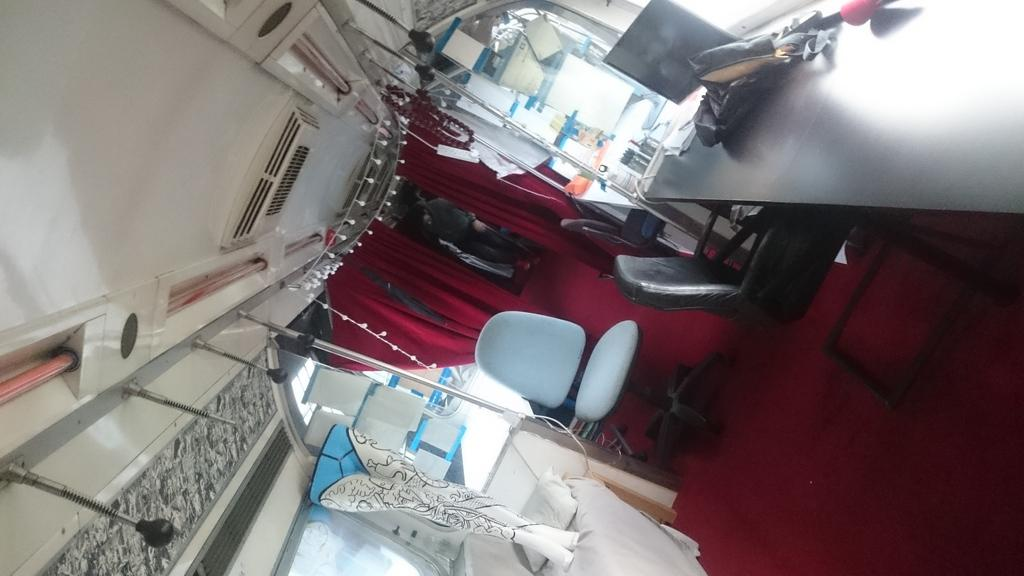What type of furniture is present in the image? There is a bed and chairs in the image. What can be found on the bed? There is a pillow on the bed. What type of windows are in the image? There are glass windows in the image. What is on the table in the image? There are objects on the table in the image. What is the color of the curtains in the background? There are maroon curtains in the background of the image. Are there any people visible in the image? Yes, there are people visible in the background of the image. What type of plantation is visible in the image? There is no plantation present in the image. How many lines can be seen in the image? The image does not contain any lines; it is a photograph of a room with furniture and people. 